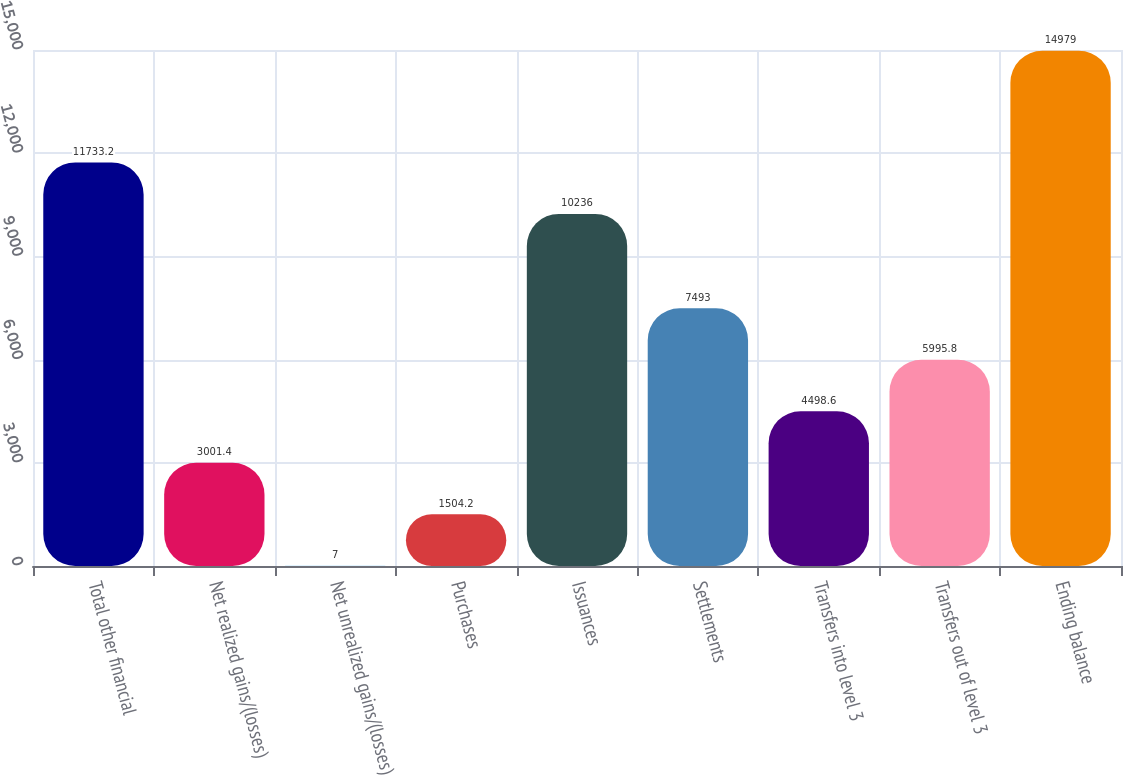Convert chart to OTSL. <chart><loc_0><loc_0><loc_500><loc_500><bar_chart><fcel>Total other financial<fcel>Net realized gains/(losses)<fcel>Net unrealized gains/(losses)<fcel>Purchases<fcel>Issuances<fcel>Settlements<fcel>Transfers into level 3<fcel>Transfers out of level 3<fcel>Ending balance<nl><fcel>11733.2<fcel>3001.4<fcel>7<fcel>1504.2<fcel>10236<fcel>7493<fcel>4498.6<fcel>5995.8<fcel>14979<nl></chart> 